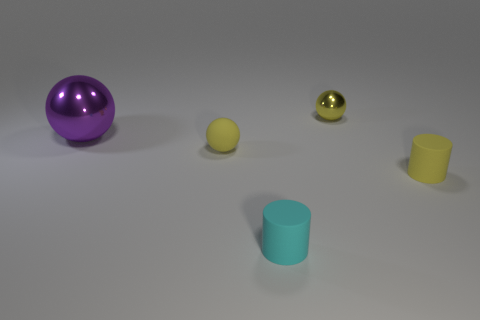Are there any other things that are the same size as the purple metal object?
Give a very brief answer. No. Is the yellow shiny object the same shape as the big metallic thing?
Provide a succinct answer. Yes. Is there any other thing that has the same shape as the big metallic object?
Your answer should be compact. Yes. Is there a tiny rubber thing?
Provide a succinct answer. Yes. There is a purple metal object; is it the same shape as the yellow thing that is to the left of the cyan matte thing?
Keep it short and to the point. Yes. What is the material of the small yellow sphere that is in front of the tiny ball that is on the right side of the tiny cyan rubber thing?
Your response must be concise. Rubber. The big ball is what color?
Your answer should be compact. Purple. There is a tiny cylinder right of the small yellow metallic thing; is its color the same as the small sphere to the left of the yellow metallic ball?
Provide a short and direct response. Yes. The yellow shiny thing that is the same shape as the big purple metallic thing is what size?
Provide a succinct answer. Small. Are there any tiny rubber things that have the same color as the big metal object?
Your answer should be compact. No. 